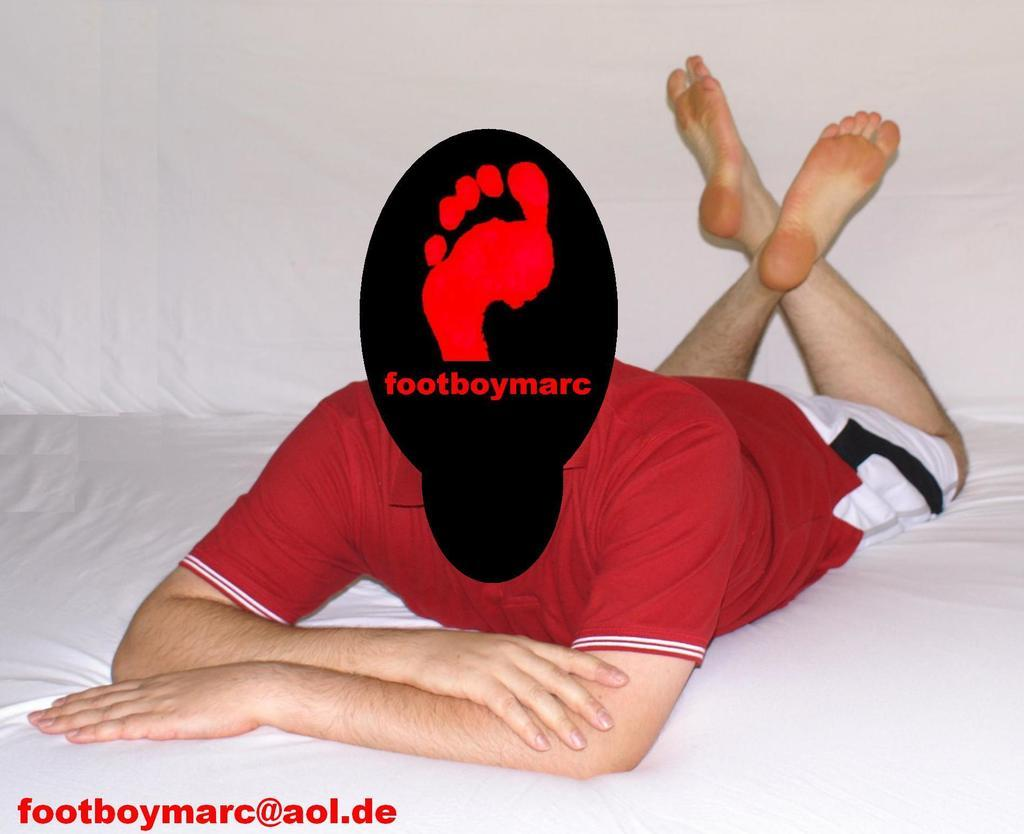<image>
Summarize the visual content of the image. A red t shirt man lyingdown in a bed whose face morphed with a design footboymarc. 